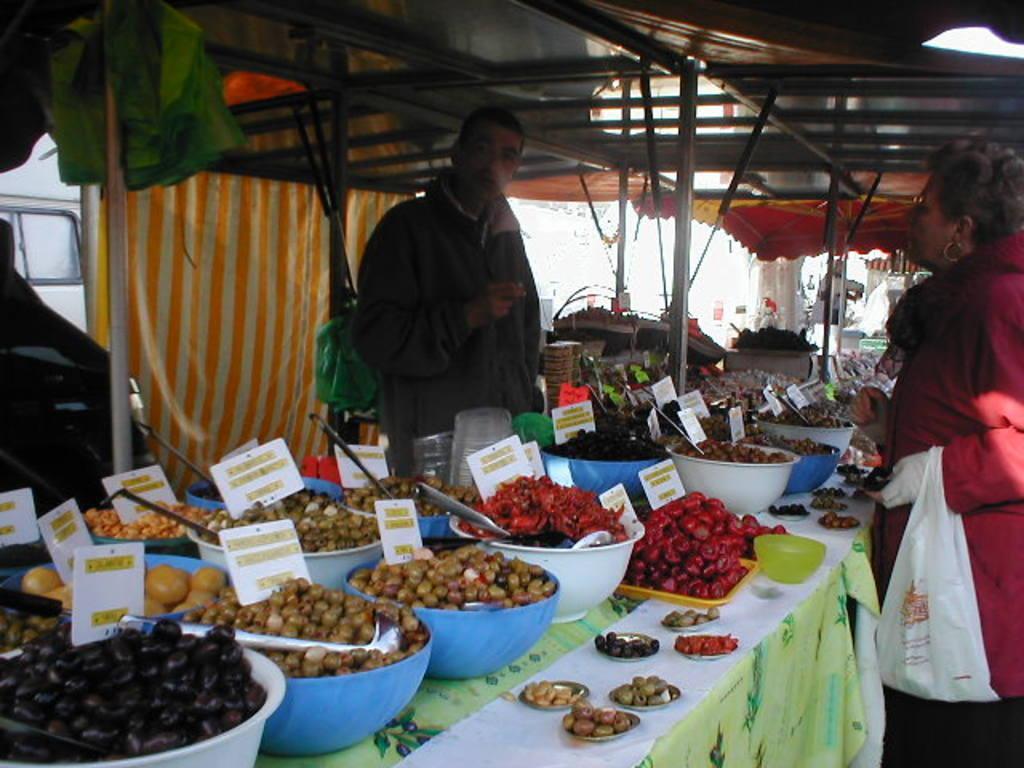How would you summarize this image in a sentence or two? In this image a person is standing behind the table having bowls, plates. Right side there is a woman carrying a bag. They are under a tent. Bowls and plates are having food and price boards in it. Left side there is a vehicle. 